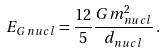Convert formula to latex. <formula><loc_0><loc_0><loc_500><loc_500>E _ { G \, n u c l } = \frac { 1 2 } { 5 } \frac { G m ^ { 2 } _ { n u c l } } { d _ { n u c l } } \, .</formula> 